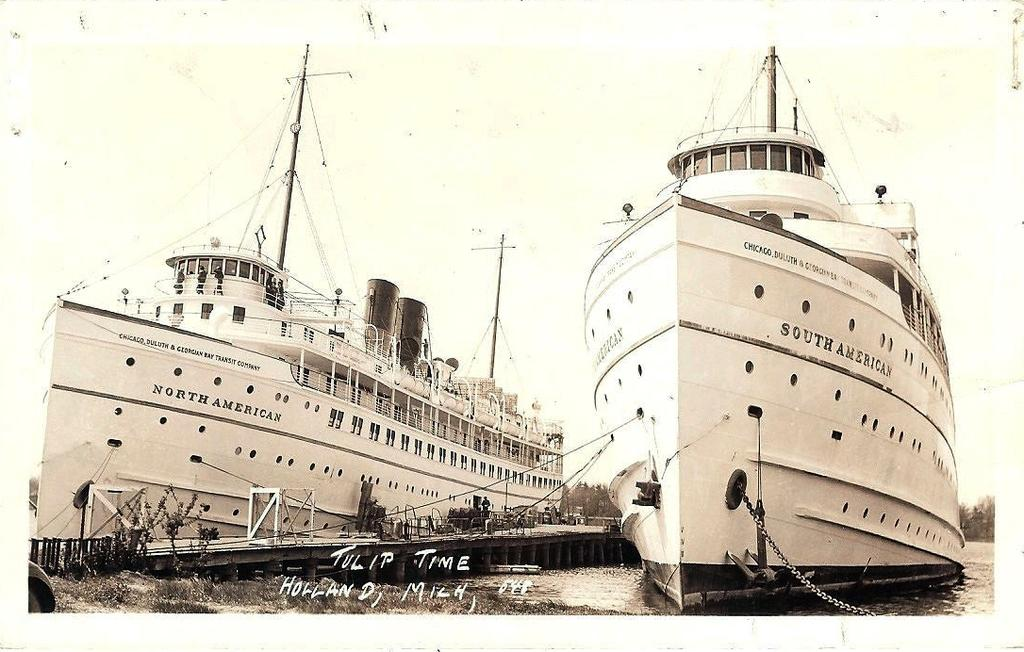<image>
Summarize the visual content of the image. A North American ship is next to a South American ship. 